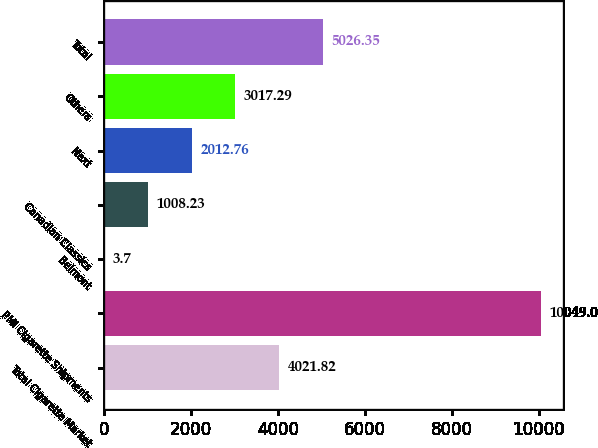Convert chart to OTSL. <chart><loc_0><loc_0><loc_500><loc_500><bar_chart><fcel>Total Cigarette Market<fcel>PMI Cigarette Shipments<fcel>Belmont<fcel>Canadian Classics<fcel>Next<fcel>Others<fcel>Total<nl><fcel>4021.82<fcel>10049<fcel>3.7<fcel>1008.23<fcel>2012.76<fcel>3017.29<fcel>5026.35<nl></chart> 